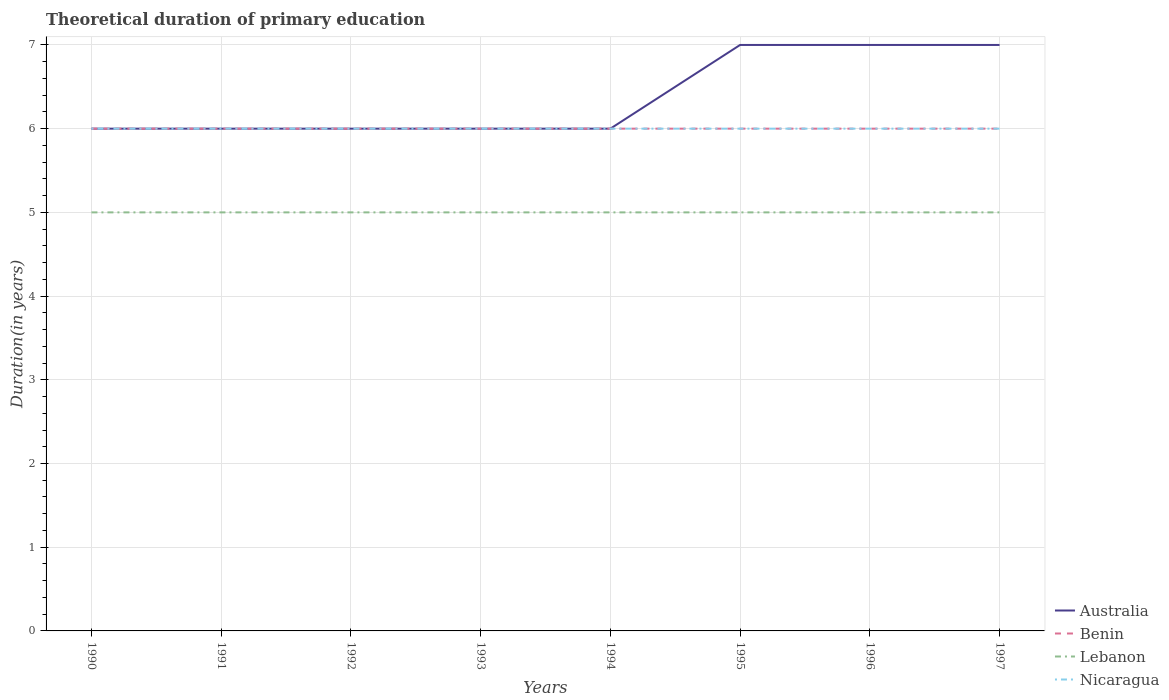How many different coloured lines are there?
Offer a very short reply. 4. Does the line corresponding to Lebanon intersect with the line corresponding to Australia?
Provide a succinct answer. No. Across all years, what is the maximum total theoretical duration of primary education in Lebanon?
Offer a terse response. 5. In which year was the total theoretical duration of primary education in Benin maximum?
Offer a very short reply. 1990. What is the total total theoretical duration of primary education in Lebanon in the graph?
Your answer should be compact. 0. What is the difference between the highest and the lowest total theoretical duration of primary education in Lebanon?
Provide a succinct answer. 0. Is the total theoretical duration of primary education in Nicaragua strictly greater than the total theoretical duration of primary education in Benin over the years?
Your response must be concise. No. How many years are there in the graph?
Your response must be concise. 8. Does the graph contain any zero values?
Your answer should be compact. No. Does the graph contain grids?
Your answer should be very brief. Yes. How are the legend labels stacked?
Offer a terse response. Vertical. What is the title of the graph?
Your answer should be very brief. Theoretical duration of primary education. What is the label or title of the X-axis?
Your response must be concise. Years. What is the label or title of the Y-axis?
Your response must be concise. Duration(in years). What is the Duration(in years) in Benin in 1990?
Make the answer very short. 6. What is the Duration(in years) of Lebanon in 1990?
Offer a terse response. 5. What is the Duration(in years) in Nicaragua in 1990?
Your answer should be compact. 6. What is the Duration(in years) in Benin in 1991?
Offer a very short reply. 6. What is the Duration(in years) of Lebanon in 1991?
Ensure brevity in your answer.  5. What is the Duration(in years) in Nicaragua in 1991?
Your answer should be very brief. 6. What is the Duration(in years) of Benin in 1992?
Keep it short and to the point. 6. What is the Duration(in years) in Lebanon in 1992?
Make the answer very short. 5. What is the Duration(in years) of Nicaragua in 1992?
Your response must be concise. 6. What is the Duration(in years) of Australia in 1993?
Ensure brevity in your answer.  6. What is the Duration(in years) in Benin in 1993?
Your answer should be compact. 6. What is the Duration(in years) of Lebanon in 1993?
Ensure brevity in your answer.  5. What is the Duration(in years) of Nicaragua in 1993?
Keep it short and to the point. 6. What is the Duration(in years) in Lebanon in 1994?
Provide a short and direct response. 5. What is the Duration(in years) in Nicaragua in 1994?
Your answer should be compact. 6. What is the Duration(in years) of Australia in 1995?
Offer a terse response. 7. What is the Duration(in years) of Benin in 1995?
Provide a succinct answer. 6. What is the Duration(in years) of Lebanon in 1995?
Ensure brevity in your answer.  5. What is the Duration(in years) in Lebanon in 1996?
Provide a short and direct response. 5. What is the Duration(in years) in Nicaragua in 1996?
Provide a short and direct response. 6. What is the Duration(in years) in Nicaragua in 1997?
Provide a short and direct response. 6. Across all years, what is the maximum Duration(in years) in Australia?
Your answer should be very brief. 7. Across all years, what is the maximum Duration(in years) of Benin?
Make the answer very short. 6. Across all years, what is the maximum Duration(in years) of Lebanon?
Make the answer very short. 5. Across all years, what is the maximum Duration(in years) in Nicaragua?
Your answer should be compact. 6. Across all years, what is the minimum Duration(in years) of Australia?
Offer a very short reply. 6. Across all years, what is the minimum Duration(in years) of Benin?
Give a very brief answer. 6. Across all years, what is the minimum Duration(in years) of Lebanon?
Your answer should be compact. 5. What is the total Duration(in years) in Australia in the graph?
Offer a terse response. 51. What is the total Duration(in years) of Nicaragua in the graph?
Offer a terse response. 48. What is the difference between the Duration(in years) of Australia in 1990 and that in 1991?
Ensure brevity in your answer.  0. What is the difference between the Duration(in years) of Benin in 1990 and that in 1991?
Offer a terse response. 0. What is the difference between the Duration(in years) in Lebanon in 1990 and that in 1991?
Ensure brevity in your answer.  0. What is the difference between the Duration(in years) of Australia in 1990 and that in 1992?
Give a very brief answer. 0. What is the difference between the Duration(in years) of Benin in 1990 and that in 1992?
Your response must be concise. 0. What is the difference between the Duration(in years) in Lebanon in 1990 and that in 1992?
Your answer should be very brief. 0. What is the difference between the Duration(in years) in Nicaragua in 1990 and that in 1992?
Your answer should be compact. 0. What is the difference between the Duration(in years) of Australia in 1990 and that in 1993?
Offer a very short reply. 0. What is the difference between the Duration(in years) of Benin in 1990 and that in 1993?
Offer a terse response. 0. What is the difference between the Duration(in years) of Lebanon in 1990 and that in 1993?
Give a very brief answer. 0. What is the difference between the Duration(in years) of Nicaragua in 1990 and that in 1993?
Keep it short and to the point. 0. What is the difference between the Duration(in years) of Benin in 1990 and that in 1994?
Give a very brief answer. 0. What is the difference between the Duration(in years) of Lebanon in 1990 and that in 1994?
Make the answer very short. 0. What is the difference between the Duration(in years) of Nicaragua in 1990 and that in 1994?
Provide a short and direct response. 0. What is the difference between the Duration(in years) in Australia in 1990 and that in 1995?
Your answer should be compact. -1. What is the difference between the Duration(in years) in Benin in 1990 and that in 1995?
Offer a very short reply. 0. What is the difference between the Duration(in years) of Lebanon in 1990 and that in 1995?
Your response must be concise. 0. What is the difference between the Duration(in years) of Lebanon in 1990 and that in 1997?
Ensure brevity in your answer.  0. What is the difference between the Duration(in years) of Australia in 1991 and that in 1992?
Ensure brevity in your answer.  0. What is the difference between the Duration(in years) of Benin in 1991 and that in 1992?
Offer a very short reply. 0. What is the difference between the Duration(in years) of Lebanon in 1991 and that in 1992?
Keep it short and to the point. 0. What is the difference between the Duration(in years) in Australia in 1991 and that in 1993?
Your response must be concise. 0. What is the difference between the Duration(in years) of Nicaragua in 1991 and that in 1993?
Provide a short and direct response. 0. What is the difference between the Duration(in years) in Benin in 1991 and that in 1994?
Your response must be concise. 0. What is the difference between the Duration(in years) of Lebanon in 1991 and that in 1994?
Your response must be concise. 0. What is the difference between the Duration(in years) in Benin in 1991 and that in 1995?
Your answer should be very brief. 0. What is the difference between the Duration(in years) of Nicaragua in 1991 and that in 1995?
Give a very brief answer. 0. What is the difference between the Duration(in years) of Nicaragua in 1991 and that in 1996?
Keep it short and to the point. 0. What is the difference between the Duration(in years) in Benin in 1991 and that in 1997?
Offer a very short reply. 0. What is the difference between the Duration(in years) of Lebanon in 1991 and that in 1997?
Your answer should be compact. 0. What is the difference between the Duration(in years) in Benin in 1992 and that in 1993?
Provide a short and direct response. 0. What is the difference between the Duration(in years) in Lebanon in 1992 and that in 1993?
Your answer should be very brief. 0. What is the difference between the Duration(in years) in Nicaragua in 1992 and that in 1993?
Give a very brief answer. 0. What is the difference between the Duration(in years) in Australia in 1992 and that in 1994?
Your answer should be compact. 0. What is the difference between the Duration(in years) in Benin in 1992 and that in 1994?
Offer a very short reply. 0. What is the difference between the Duration(in years) of Lebanon in 1992 and that in 1994?
Your answer should be compact. 0. What is the difference between the Duration(in years) in Australia in 1992 and that in 1995?
Your answer should be compact. -1. What is the difference between the Duration(in years) of Benin in 1992 and that in 1995?
Offer a very short reply. 0. What is the difference between the Duration(in years) in Lebanon in 1992 and that in 1995?
Provide a succinct answer. 0. What is the difference between the Duration(in years) of Nicaragua in 1992 and that in 1995?
Offer a very short reply. 0. What is the difference between the Duration(in years) of Australia in 1992 and that in 1996?
Keep it short and to the point. -1. What is the difference between the Duration(in years) in Benin in 1992 and that in 1996?
Ensure brevity in your answer.  0. What is the difference between the Duration(in years) in Nicaragua in 1992 and that in 1996?
Provide a short and direct response. 0. What is the difference between the Duration(in years) of Benin in 1992 and that in 1997?
Offer a terse response. 0. What is the difference between the Duration(in years) of Nicaragua in 1992 and that in 1997?
Your answer should be very brief. 0. What is the difference between the Duration(in years) in Australia in 1993 and that in 1994?
Ensure brevity in your answer.  0. What is the difference between the Duration(in years) of Nicaragua in 1993 and that in 1994?
Make the answer very short. 0. What is the difference between the Duration(in years) of Benin in 1993 and that in 1995?
Your answer should be very brief. 0. What is the difference between the Duration(in years) in Nicaragua in 1993 and that in 1995?
Provide a succinct answer. 0. What is the difference between the Duration(in years) of Australia in 1993 and that in 1996?
Provide a short and direct response. -1. What is the difference between the Duration(in years) in Benin in 1993 and that in 1996?
Your answer should be compact. 0. What is the difference between the Duration(in years) of Lebanon in 1993 and that in 1996?
Provide a short and direct response. 0. What is the difference between the Duration(in years) of Lebanon in 1993 and that in 1997?
Your response must be concise. 0. What is the difference between the Duration(in years) in Australia in 1994 and that in 1996?
Provide a short and direct response. -1. What is the difference between the Duration(in years) of Australia in 1994 and that in 1997?
Your answer should be compact. -1. What is the difference between the Duration(in years) of Benin in 1994 and that in 1997?
Ensure brevity in your answer.  0. What is the difference between the Duration(in years) of Lebanon in 1994 and that in 1997?
Your answer should be very brief. 0. What is the difference between the Duration(in years) in Nicaragua in 1994 and that in 1997?
Ensure brevity in your answer.  0. What is the difference between the Duration(in years) of Australia in 1995 and that in 1996?
Offer a very short reply. 0. What is the difference between the Duration(in years) in Benin in 1995 and that in 1996?
Make the answer very short. 0. What is the difference between the Duration(in years) in Benin in 1995 and that in 1997?
Provide a short and direct response. 0. What is the difference between the Duration(in years) in Lebanon in 1995 and that in 1997?
Give a very brief answer. 0. What is the difference between the Duration(in years) in Benin in 1996 and that in 1997?
Your answer should be compact. 0. What is the difference between the Duration(in years) in Lebanon in 1996 and that in 1997?
Offer a very short reply. 0. What is the difference between the Duration(in years) in Nicaragua in 1996 and that in 1997?
Give a very brief answer. 0. What is the difference between the Duration(in years) in Australia in 1990 and the Duration(in years) in Nicaragua in 1991?
Your answer should be very brief. 0. What is the difference between the Duration(in years) of Benin in 1990 and the Duration(in years) of Lebanon in 1991?
Offer a terse response. 1. What is the difference between the Duration(in years) of Lebanon in 1990 and the Duration(in years) of Nicaragua in 1991?
Your answer should be compact. -1. What is the difference between the Duration(in years) of Australia in 1990 and the Duration(in years) of Benin in 1992?
Your answer should be compact. 0. What is the difference between the Duration(in years) of Benin in 1990 and the Duration(in years) of Lebanon in 1992?
Your response must be concise. 1. What is the difference between the Duration(in years) in Benin in 1990 and the Duration(in years) in Nicaragua in 1992?
Offer a terse response. 0. What is the difference between the Duration(in years) of Lebanon in 1990 and the Duration(in years) of Nicaragua in 1992?
Provide a short and direct response. -1. What is the difference between the Duration(in years) in Australia in 1990 and the Duration(in years) in Lebanon in 1993?
Make the answer very short. 1. What is the difference between the Duration(in years) of Benin in 1990 and the Duration(in years) of Lebanon in 1993?
Make the answer very short. 1. What is the difference between the Duration(in years) of Benin in 1990 and the Duration(in years) of Nicaragua in 1993?
Offer a very short reply. 0. What is the difference between the Duration(in years) of Australia in 1990 and the Duration(in years) of Benin in 1994?
Provide a succinct answer. 0. What is the difference between the Duration(in years) in Australia in 1990 and the Duration(in years) in Lebanon in 1994?
Offer a terse response. 1. What is the difference between the Duration(in years) in Australia in 1990 and the Duration(in years) in Nicaragua in 1994?
Keep it short and to the point. 0. What is the difference between the Duration(in years) of Benin in 1990 and the Duration(in years) of Nicaragua in 1994?
Provide a short and direct response. 0. What is the difference between the Duration(in years) of Australia in 1990 and the Duration(in years) of Benin in 1995?
Provide a short and direct response. 0. What is the difference between the Duration(in years) in Australia in 1990 and the Duration(in years) in Nicaragua in 1995?
Keep it short and to the point. 0. What is the difference between the Duration(in years) of Lebanon in 1990 and the Duration(in years) of Nicaragua in 1995?
Your answer should be very brief. -1. What is the difference between the Duration(in years) of Benin in 1990 and the Duration(in years) of Lebanon in 1996?
Give a very brief answer. 1. What is the difference between the Duration(in years) in Benin in 1990 and the Duration(in years) in Nicaragua in 1996?
Provide a succinct answer. 0. What is the difference between the Duration(in years) of Lebanon in 1990 and the Duration(in years) of Nicaragua in 1996?
Offer a very short reply. -1. What is the difference between the Duration(in years) in Australia in 1990 and the Duration(in years) in Benin in 1997?
Offer a terse response. 0. What is the difference between the Duration(in years) in Australia in 1991 and the Duration(in years) in Lebanon in 1992?
Make the answer very short. 1. What is the difference between the Duration(in years) in Australia in 1991 and the Duration(in years) in Nicaragua in 1992?
Ensure brevity in your answer.  0. What is the difference between the Duration(in years) in Australia in 1991 and the Duration(in years) in Benin in 1993?
Provide a succinct answer. 0. What is the difference between the Duration(in years) in Australia in 1991 and the Duration(in years) in Nicaragua in 1993?
Ensure brevity in your answer.  0. What is the difference between the Duration(in years) of Lebanon in 1991 and the Duration(in years) of Nicaragua in 1994?
Offer a terse response. -1. What is the difference between the Duration(in years) of Australia in 1991 and the Duration(in years) of Benin in 1995?
Make the answer very short. 0. What is the difference between the Duration(in years) of Australia in 1991 and the Duration(in years) of Lebanon in 1995?
Your response must be concise. 1. What is the difference between the Duration(in years) in Benin in 1991 and the Duration(in years) in Lebanon in 1995?
Your response must be concise. 1. What is the difference between the Duration(in years) of Benin in 1991 and the Duration(in years) of Nicaragua in 1995?
Ensure brevity in your answer.  0. What is the difference between the Duration(in years) in Lebanon in 1991 and the Duration(in years) in Nicaragua in 1995?
Your answer should be very brief. -1. What is the difference between the Duration(in years) in Australia in 1991 and the Duration(in years) in Benin in 1996?
Provide a succinct answer. 0. What is the difference between the Duration(in years) in Australia in 1991 and the Duration(in years) in Lebanon in 1996?
Keep it short and to the point. 1. What is the difference between the Duration(in years) of Benin in 1991 and the Duration(in years) of Lebanon in 1996?
Keep it short and to the point. 1. What is the difference between the Duration(in years) in Benin in 1991 and the Duration(in years) in Nicaragua in 1996?
Offer a very short reply. 0. What is the difference between the Duration(in years) in Australia in 1991 and the Duration(in years) in Benin in 1997?
Your response must be concise. 0. What is the difference between the Duration(in years) in Benin in 1992 and the Duration(in years) in Lebanon in 1993?
Ensure brevity in your answer.  1. What is the difference between the Duration(in years) of Australia in 1992 and the Duration(in years) of Benin in 1994?
Provide a short and direct response. 0. What is the difference between the Duration(in years) in Benin in 1992 and the Duration(in years) in Nicaragua in 1994?
Your answer should be compact. 0. What is the difference between the Duration(in years) of Lebanon in 1992 and the Duration(in years) of Nicaragua in 1994?
Offer a terse response. -1. What is the difference between the Duration(in years) in Australia in 1992 and the Duration(in years) in Lebanon in 1995?
Provide a succinct answer. 1. What is the difference between the Duration(in years) in Australia in 1992 and the Duration(in years) in Nicaragua in 1995?
Offer a terse response. 0. What is the difference between the Duration(in years) of Lebanon in 1992 and the Duration(in years) of Nicaragua in 1995?
Your answer should be compact. -1. What is the difference between the Duration(in years) of Australia in 1992 and the Duration(in years) of Lebanon in 1996?
Give a very brief answer. 1. What is the difference between the Duration(in years) in Benin in 1992 and the Duration(in years) in Lebanon in 1996?
Ensure brevity in your answer.  1. What is the difference between the Duration(in years) in Benin in 1992 and the Duration(in years) in Nicaragua in 1996?
Provide a short and direct response. 0. What is the difference between the Duration(in years) in Lebanon in 1992 and the Duration(in years) in Nicaragua in 1996?
Make the answer very short. -1. What is the difference between the Duration(in years) of Australia in 1992 and the Duration(in years) of Nicaragua in 1997?
Offer a very short reply. 0. What is the difference between the Duration(in years) in Benin in 1992 and the Duration(in years) in Lebanon in 1997?
Ensure brevity in your answer.  1. What is the difference between the Duration(in years) in Benin in 1992 and the Duration(in years) in Nicaragua in 1997?
Your answer should be compact. 0. What is the difference between the Duration(in years) of Australia in 1993 and the Duration(in years) of Nicaragua in 1994?
Your response must be concise. 0. What is the difference between the Duration(in years) of Benin in 1993 and the Duration(in years) of Lebanon in 1994?
Your answer should be compact. 1. What is the difference between the Duration(in years) of Benin in 1993 and the Duration(in years) of Nicaragua in 1994?
Your response must be concise. 0. What is the difference between the Duration(in years) in Lebanon in 1993 and the Duration(in years) in Nicaragua in 1994?
Provide a succinct answer. -1. What is the difference between the Duration(in years) of Australia in 1993 and the Duration(in years) of Benin in 1995?
Your answer should be very brief. 0. What is the difference between the Duration(in years) in Australia in 1993 and the Duration(in years) in Nicaragua in 1995?
Your answer should be very brief. 0. What is the difference between the Duration(in years) of Benin in 1993 and the Duration(in years) of Lebanon in 1995?
Your answer should be compact. 1. What is the difference between the Duration(in years) of Australia in 1993 and the Duration(in years) of Lebanon in 1996?
Offer a very short reply. 1. What is the difference between the Duration(in years) of Australia in 1993 and the Duration(in years) of Nicaragua in 1996?
Offer a very short reply. 0. What is the difference between the Duration(in years) in Benin in 1993 and the Duration(in years) in Nicaragua in 1996?
Provide a succinct answer. 0. What is the difference between the Duration(in years) of Lebanon in 1993 and the Duration(in years) of Nicaragua in 1996?
Offer a terse response. -1. What is the difference between the Duration(in years) in Australia in 1993 and the Duration(in years) in Nicaragua in 1997?
Keep it short and to the point. 0. What is the difference between the Duration(in years) in Benin in 1993 and the Duration(in years) in Nicaragua in 1997?
Your answer should be compact. 0. What is the difference between the Duration(in years) of Lebanon in 1993 and the Duration(in years) of Nicaragua in 1997?
Your response must be concise. -1. What is the difference between the Duration(in years) of Australia in 1994 and the Duration(in years) of Benin in 1995?
Your answer should be compact. 0. What is the difference between the Duration(in years) in Benin in 1994 and the Duration(in years) in Lebanon in 1995?
Give a very brief answer. 1. What is the difference between the Duration(in years) of Benin in 1994 and the Duration(in years) of Nicaragua in 1995?
Your answer should be compact. 0. What is the difference between the Duration(in years) of Australia in 1994 and the Duration(in years) of Benin in 1996?
Your answer should be compact. 0. What is the difference between the Duration(in years) in Australia in 1994 and the Duration(in years) in Nicaragua in 1996?
Offer a very short reply. 0. What is the difference between the Duration(in years) in Lebanon in 1994 and the Duration(in years) in Nicaragua in 1996?
Make the answer very short. -1. What is the difference between the Duration(in years) in Australia in 1994 and the Duration(in years) in Lebanon in 1997?
Offer a terse response. 1. What is the difference between the Duration(in years) of Benin in 1994 and the Duration(in years) of Lebanon in 1997?
Keep it short and to the point. 1. What is the difference between the Duration(in years) in Australia in 1995 and the Duration(in years) in Benin in 1996?
Provide a succinct answer. 1. What is the difference between the Duration(in years) in Australia in 1995 and the Duration(in years) in Nicaragua in 1996?
Offer a terse response. 1. What is the difference between the Duration(in years) in Benin in 1995 and the Duration(in years) in Nicaragua in 1996?
Your response must be concise. 0. What is the difference between the Duration(in years) in Australia in 1995 and the Duration(in years) in Benin in 1997?
Your response must be concise. 1. What is the difference between the Duration(in years) of Australia in 1995 and the Duration(in years) of Lebanon in 1997?
Provide a short and direct response. 2. What is the difference between the Duration(in years) in Australia in 1995 and the Duration(in years) in Nicaragua in 1997?
Offer a terse response. 1. What is the difference between the Duration(in years) of Benin in 1995 and the Duration(in years) of Lebanon in 1997?
Your response must be concise. 1. What is the difference between the Duration(in years) of Benin in 1995 and the Duration(in years) of Nicaragua in 1997?
Offer a very short reply. 0. What is the difference between the Duration(in years) in Australia in 1996 and the Duration(in years) in Benin in 1997?
Make the answer very short. 1. What is the difference between the Duration(in years) of Australia in 1996 and the Duration(in years) of Lebanon in 1997?
Provide a short and direct response. 2. What is the difference between the Duration(in years) in Australia in 1996 and the Duration(in years) in Nicaragua in 1997?
Provide a succinct answer. 1. What is the difference between the Duration(in years) of Benin in 1996 and the Duration(in years) of Nicaragua in 1997?
Offer a very short reply. 0. What is the average Duration(in years) of Australia per year?
Your answer should be compact. 6.38. What is the average Duration(in years) in Nicaragua per year?
Your answer should be very brief. 6. In the year 1990, what is the difference between the Duration(in years) in Australia and Duration(in years) in Lebanon?
Give a very brief answer. 1. In the year 1990, what is the difference between the Duration(in years) in Benin and Duration(in years) in Lebanon?
Your answer should be very brief. 1. In the year 1990, what is the difference between the Duration(in years) in Benin and Duration(in years) in Nicaragua?
Make the answer very short. 0. In the year 1991, what is the difference between the Duration(in years) in Benin and Duration(in years) in Lebanon?
Offer a very short reply. 1. In the year 1991, what is the difference between the Duration(in years) in Benin and Duration(in years) in Nicaragua?
Provide a short and direct response. 0. In the year 1991, what is the difference between the Duration(in years) in Lebanon and Duration(in years) in Nicaragua?
Your answer should be very brief. -1. In the year 1993, what is the difference between the Duration(in years) in Australia and Duration(in years) in Benin?
Ensure brevity in your answer.  0. In the year 1993, what is the difference between the Duration(in years) in Australia and Duration(in years) in Lebanon?
Keep it short and to the point. 1. In the year 1993, what is the difference between the Duration(in years) of Australia and Duration(in years) of Nicaragua?
Ensure brevity in your answer.  0. In the year 1993, what is the difference between the Duration(in years) of Benin and Duration(in years) of Lebanon?
Your answer should be compact. 1. In the year 1993, what is the difference between the Duration(in years) of Benin and Duration(in years) of Nicaragua?
Ensure brevity in your answer.  0. In the year 1993, what is the difference between the Duration(in years) in Lebanon and Duration(in years) in Nicaragua?
Your response must be concise. -1. In the year 1994, what is the difference between the Duration(in years) in Australia and Duration(in years) in Benin?
Offer a terse response. 0. In the year 1994, what is the difference between the Duration(in years) in Australia and Duration(in years) in Lebanon?
Your answer should be compact. 1. In the year 1994, what is the difference between the Duration(in years) of Benin and Duration(in years) of Lebanon?
Give a very brief answer. 1. In the year 1994, what is the difference between the Duration(in years) of Benin and Duration(in years) of Nicaragua?
Ensure brevity in your answer.  0. In the year 1994, what is the difference between the Duration(in years) in Lebanon and Duration(in years) in Nicaragua?
Your answer should be very brief. -1. In the year 1995, what is the difference between the Duration(in years) in Australia and Duration(in years) in Benin?
Make the answer very short. 1. In the year 1996, what is the difference between the Duration(in years) of Australia and Duration(in years) of Nicaragua?
Your answer should be compact. 1. In the year 1997, what is the difference between the Duration(in years) in Benin and Duration(in years) in Lebanon?
Provide a succinct answer. 1. In the year 1997, what is the difference between the Duration(in years) of Lebanon and Duration(in years) of Nicaragua?
Offer a terse response. -1. What is the ratio of the Duration(in years) of Benin in 1990 to that in 1991?
Give a very brief answer. 1. What is the ratio of the Duration(in years) in Nicaragua in 1990 to that in 1991?
Ensure brevity in your answer.  1. What is the ratio of the Duration(in years) of Australia in 1990 to that in 1992?
Ensure brevity in your answer.  1. What is the ratio of the Duration(in years) of Benin in 1990 to that in 1992?
Provide a succinct answer. 1. What is the ratio of the Duration(in years) in Lebanon in 1990 to that in 1992?
Give a very brief answer. 1. What is the ratio of the Duration(in years) in Nicaragua in 1990 to that in 1992?
Offer a very short reply. 1. What is the ratio of the Duration(in years) in Lebanon in 1990 to that in 1993?
Provide a succinct answer. 1. What is the ratio of the Duration(in years) in Australia in 1990 to that in 1994?
Give a very brief answer. 1. What is the ratio of the Duration(in years) of Benin in 1990 to that in 1994?
Keep it short and to the point. 1. What is the ratio of the Duration(in years) in Australia in 1990 to that in 1995?
Give a very brief answer. 0.86. What is the ratio of the Duration(in years) in Benin in 1990 to that in 1995?
Make the answer very short. 1. What is the ratio of the Duration(in years) of Nicaragua in 1990 to that in 1995?
Provide a short and direct response. 1. What is the ratio of the Duration(in years) in Australia in 1990 to that in 1997?
Your response must be concise. 0.86. What is the ratio of the Duration(in years) in Benin in 1991 to that in 1992?
Ensure brevity in your answer.  1. What is the ratio of the Duration(in years) of Nicaragua in 1991 to that in 1992?
Your response must be concise. 1. What is the ratio of the Duration(in years) in Nicaragua in 1991 to that in 1993?
Provide a short and direct response. 1. What is the ratio of the Duration(in years) of Benin in 1991 to that in 1994?
Ensure brevity in your answer.  1. What is the ratio of the Duration(in years) of Australia in 1991 to that in 1995?
Provide a succinct answer. 0.86. What is the ratio of the Duration(in years) in Lebanon in 1991 to that in 1996?
Your answer should be very brief. 1. What is the ratio of the Duration(in years) of Benin in 1991 to that in 1997?
Offer a very short reply. 1. What is the ratio of the Duration(in years) in Lebanon in 1992 to that in 1993?
Ensure brevity in your answer.  1. What is the ratio of the Duration(in years) in Nicaragua in 1992 to that in 1993?
Give a very brief answer. 1. What is the ratio of the Duration(in years) of Nicaragua in 1992 to that in 1994?
Provide a succinct answer. 1. What is the ratio of the Duration(in years) in Lebanon in 1992 to that in 1995?
Your response must be concise. 1. What is the ratio of the Duration(in years) of Nicaragua in 1992 to that in 1995?
Your answer should be compact. 1. What is the ratio of the Duration(in years) in Australia in 1992 to that in 1996?
Ensure brevity in your answer.  0.86. What is the ratio of the Duration(in years) in Lebanon in 1992 to that in 1996?
Your answer should be compact. 1. What is the ratio of the Duration(in years) in Nicaragua in 1992 to that in 1996?
Give a very brief answer. 1. What is the ratio of the Duration(in years) in Benin in 1992 to that in 1997?
Your answer should be very brief. 1. What is the ratio of the Duration(in years) in Benin in 1993 to that in 1994?
Offer a terse response. 1. What is the ratio of the Duration(in years) in Lebanon in 1993 to that in 1994?
Give a very brief answer. 1. What is the ratio of the Duration(in years) in Nicaragua in 1993 to that in 1994?
Ensure brevity in your answer.  1. What is the ratio of the Duration(in years) of Benin in 1993 to that in 1995?
Your answer should be very brief. 1. What is the ratio of the Duration(in years) of Lebanon in 1993 to that in 1995?
Keep it short and to the point. 1. What is the ratio of the Duration(in years) of Australia in 1993 to that in 1996?
Your response must be concise. 0.86. What is the ratio of the Duration(in years) of Australia in 1993 to that in 1997?
Offer a terse response. 0.86. What is the ratio of the Duration(in years) of Benin in 1993 to that in 1997?
Your answer should be compact. 1. What is the ratio of the Duration(in years) in Lebanon in 1993 to that in 1997?
Your answer should be very brief. 1. What is the ratio of the Duration(in years) of Benin in 1994 to that in 1995?
Your answer should be compact. 1. What is the ratio of the Duration(in years) of Lebanon in 1994 to that in 1995?
Offer a very short reply. 1. What is the ratio of the Duration(in years) in Nicaragua in 1994 to that in 1995?
Provide a short and direct response. 1. What is the ratio of the Duration(in years) in Lebanon in 1994 to that in 1997?
Keep it short and to the point. 1. What is the ratio of the Duration(in years) of Nicaragua in 1994 to that in 1997?
Your response must be concise. 1. What is the ratio of the Duration(in years) of Australia in 1995 to that in 1996?
Provide a succinct answer. 1. What is the ratio of the Duration(in years) of Nicaragua in 1995 to that in 1996?
Your answer should be compact. 1. What is the ratio of the Duration(in years) in Benin in 1995 to that in 1997?
Keep it short and to the point. 1. What is the ratio of the Duration(in years) in Benin in 1996 to that in 1997?
Offer a very short reply. 1. What is the ratio of the Duration(in years) of Lebanon in 1996 to that in 1997?
Your answer should be very brief. 1. What is the ratio of the Duration(in years) of Nicaragua in 1996 to that in 1997?
Ensure brevity in your answer.  1. What is the difference between the highest and the second highest Duration(in years) of Benin?
Offer a very short reply. 0. What is the difference between the highest and the second highest Duration(in years) in Nicaragua?
Ensure brevity in your answer.  0. What is the difference between the highest and the lowest Duration(in years) in Benin?
Keep it short and to the point. 0. What is the difference between the highest and the lowest Duration(in years) of Lebanon?
Make the answer very short. 0. What is the difference between the highest and the lowest Duration(in years) of Nicaragua?
Ensure brevity in your answer.  0. 